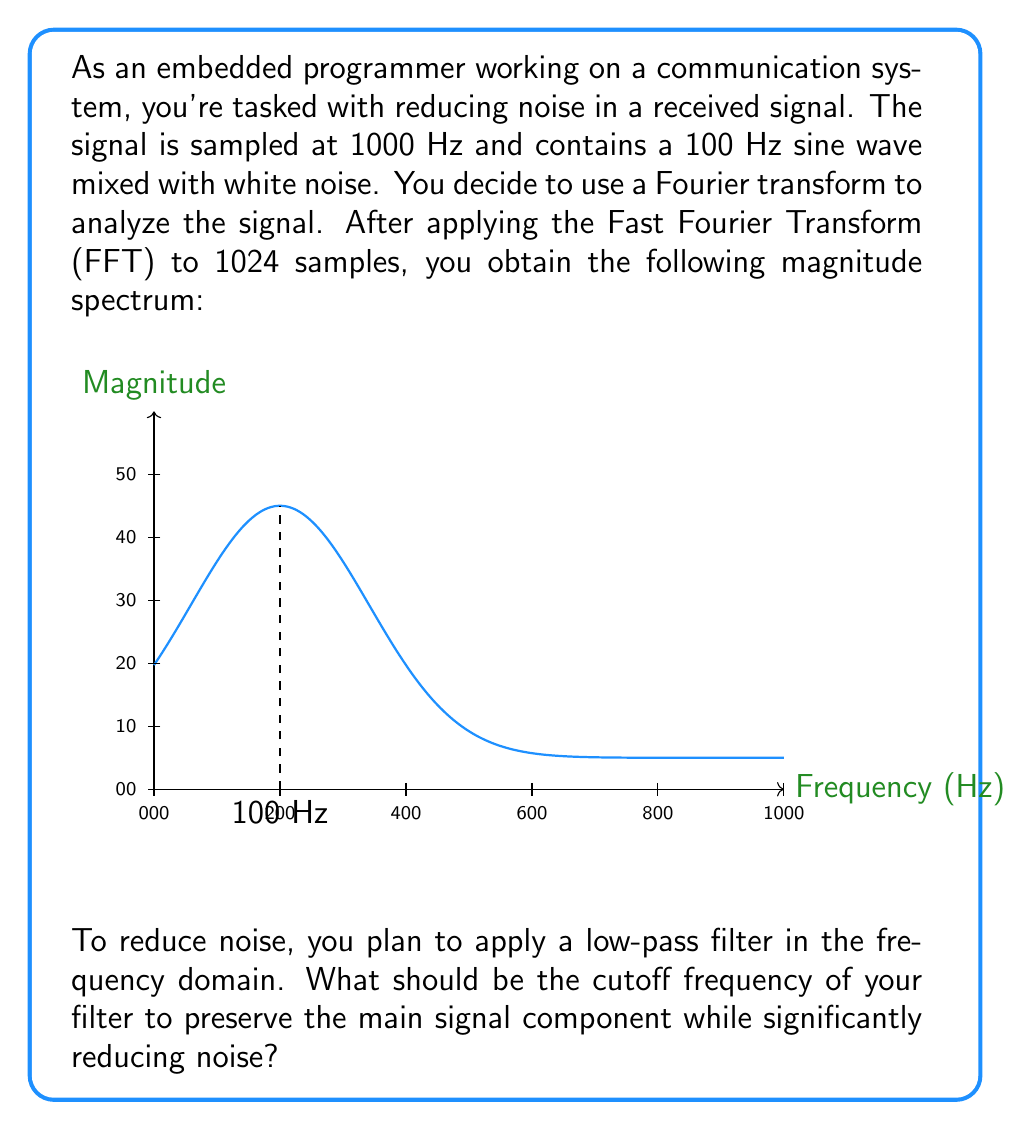Solve this math problem. Let's approach this step-by-step:

1) First, we need to identify the main signal component. From the spectrum, we can see a clear peak at 100 Hz, which corresponds to the 100 Hz sine wave mentioned in the problem statement.

2) The width of this peak is important. In an ideal case, a pure sine wave would appear as an infinitely narrow spike. However, due to the finite sample size and the presence of noise, the peak has some width.

3) To determine an appropriate cutoff frequency, we need to ensure that we include the entire main lobe of the signal peak while excluding as much noise as possible.

4) From the graph, we can estimate that the main lobe of the signal extends to about 120-130 Hz.

5) The noise appears to be relatively uniform across all frequencies (characteristic of white noise), so any cutoff above the main signal component will help reduce noise.

6) A common rule of thumb is to set the cutoff frequency at about 1.2 to 1.5 times the highest frequency of interest. In this case:

   $$f_{cutoff} = 1.3 * 100 Hz = 130 Hz$$

7) This cutoff will preserve the main signal component while significantly reducing the noise at higher frequencies.

8) In the frequency domain, you would implement this filter by setting the magnitude of all frequency components above 130 Hz to zero (or applying a smooth roll-off for better time-domain behavior).

9) After applying this filter in the frequency domain, you would then use the Inverse Fast Fourier Transform (IFFT) to convert the signal back to the time domain, resulting in a cleaner signal with reduced noise.
Answer: 130 Hz 